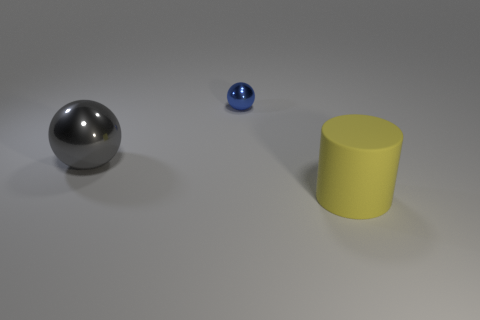Add 2 small blue balls. How many objects exist? 5 Subtract all cylinders. How many objects are left? 2 Subtract all blue spheres. How many spheres are left? 1 Subtract all gray balls. Subtract all cyan blocks. How many balls are left? 1 Subtract all purple blocks. How many blue spheres are left? 1 Subtract all blue objects. Subtract all big yellow things. How many objects are left? 1 Add 2 gray shiny balls. How many gray shiny balls are left? 3 Add 1 blue blocks. How many blue blocks exist? 1 Subtract 0 red blocks. How many objects are left? 3 Subtract 1 cylinders. How many cylinders are left? 0 